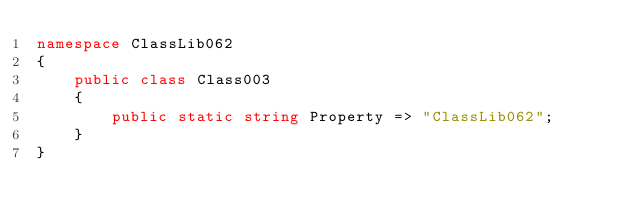Convert code to text. <code><loc_0><loc_0><loc_500><loc_500><_C#_>namespace ClassLib062
{
    public class Class003
    {
        public static string Property => "ClassLib062";
    }
}
</code> 